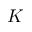<formula> <loc_0><loc_0><loc_500><loc_500>K</formula> 